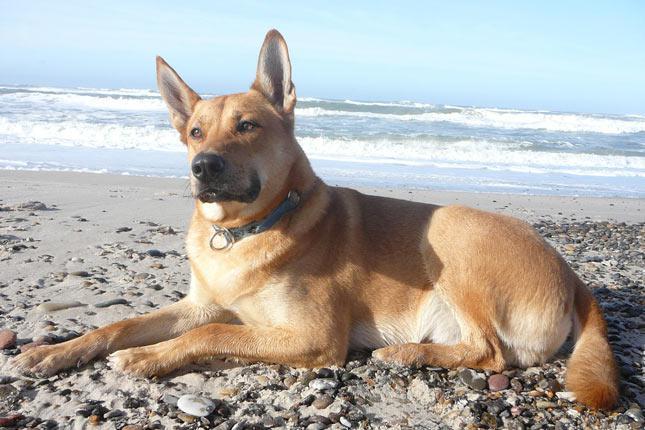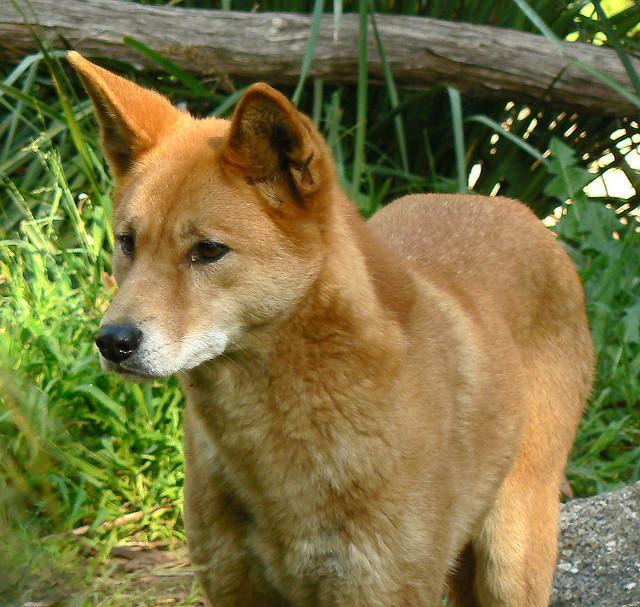The first image is the image on the left, the second image is the image on the right. For the images displayed, is the sentence "The left image shows one reclining dog with extened front paws and upright head, and the right image shows one orange dingo gazing leftward." factually correct? Answer yes or no. Yes. 